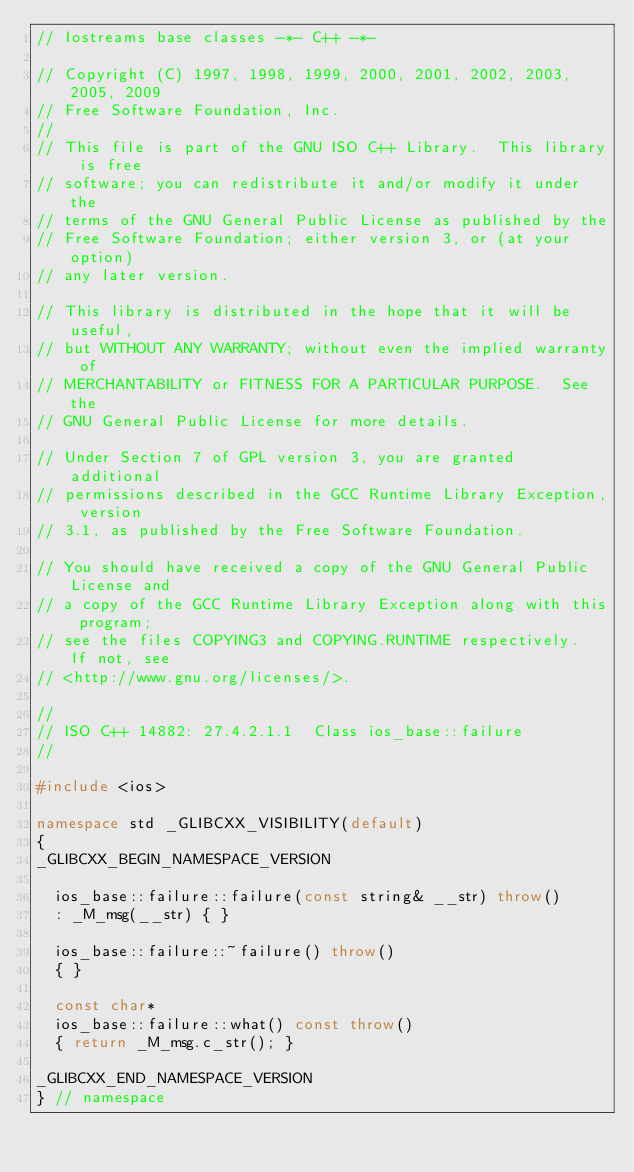Convert code to text. <code><loc_0><loc_0><loc_500><loc_500><_C++_>// Iostreams base classes -*- C++ -*-

// Copyright (C) 1997, 1998, 1999, 2000, 2001, 2002, 2003, 2005, 2009
// Free Software Foundation, Inc.
//
// This file is part of the GNU ISO C++ Library.  This library is free
// software; you can redistribute it and/or modify it under the
// terms of the GNU General Public License as published by the
// Free Software Foundation; either version 3, or (at your option)
// any later version.

// This library is distributed in the hope that it will be useful,
// but WITHOUT ANY WARRANTY; without even the implied warranty of
// MERCHANTABILITY or FITNESS FOR A PARTICULAR PURPOSE.  See the
// GNU General Public License for more details.

// Under Section 7 of GPL version 3, you are granted additional
// permissions described in the GCC Runtime Library Exception, version
// 3.1, as published by the Free Software Foundation.

// You should have received a copy of the GNU General Public License and
// a copy of the GCC Runtime Library Exception along with this program;
// see the files COPYING3 and COPYING.RUNTIME respectively.  If not, see
// <http://www.gnu.org/licenses/>.

//
// ISO C++ 14882: 27.4.2.1.1  Class ios_base::failure
//

#include <ios>

namespace std _GLIBCXX_VISIBILITY(default)
{
_GLIBCXX_BEGIN_NAMESPACE_VERSION

  ios_base::failure::failure(const string& __str) throw()
  : _M_msg(__str) { }

  ios_base::failure::~failure() throw()
  { }
  
  const char*
  ios_base::failure::what() const throw()
  { return _M_msg.c_str(); }

_GLIBCXX_END_NAMESPACE_VERSION
} // namespace
</code> 